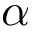Convert formula to latex. <formula><loc_0><loc_0><loc_500><loc_500>\alpha</formula> 